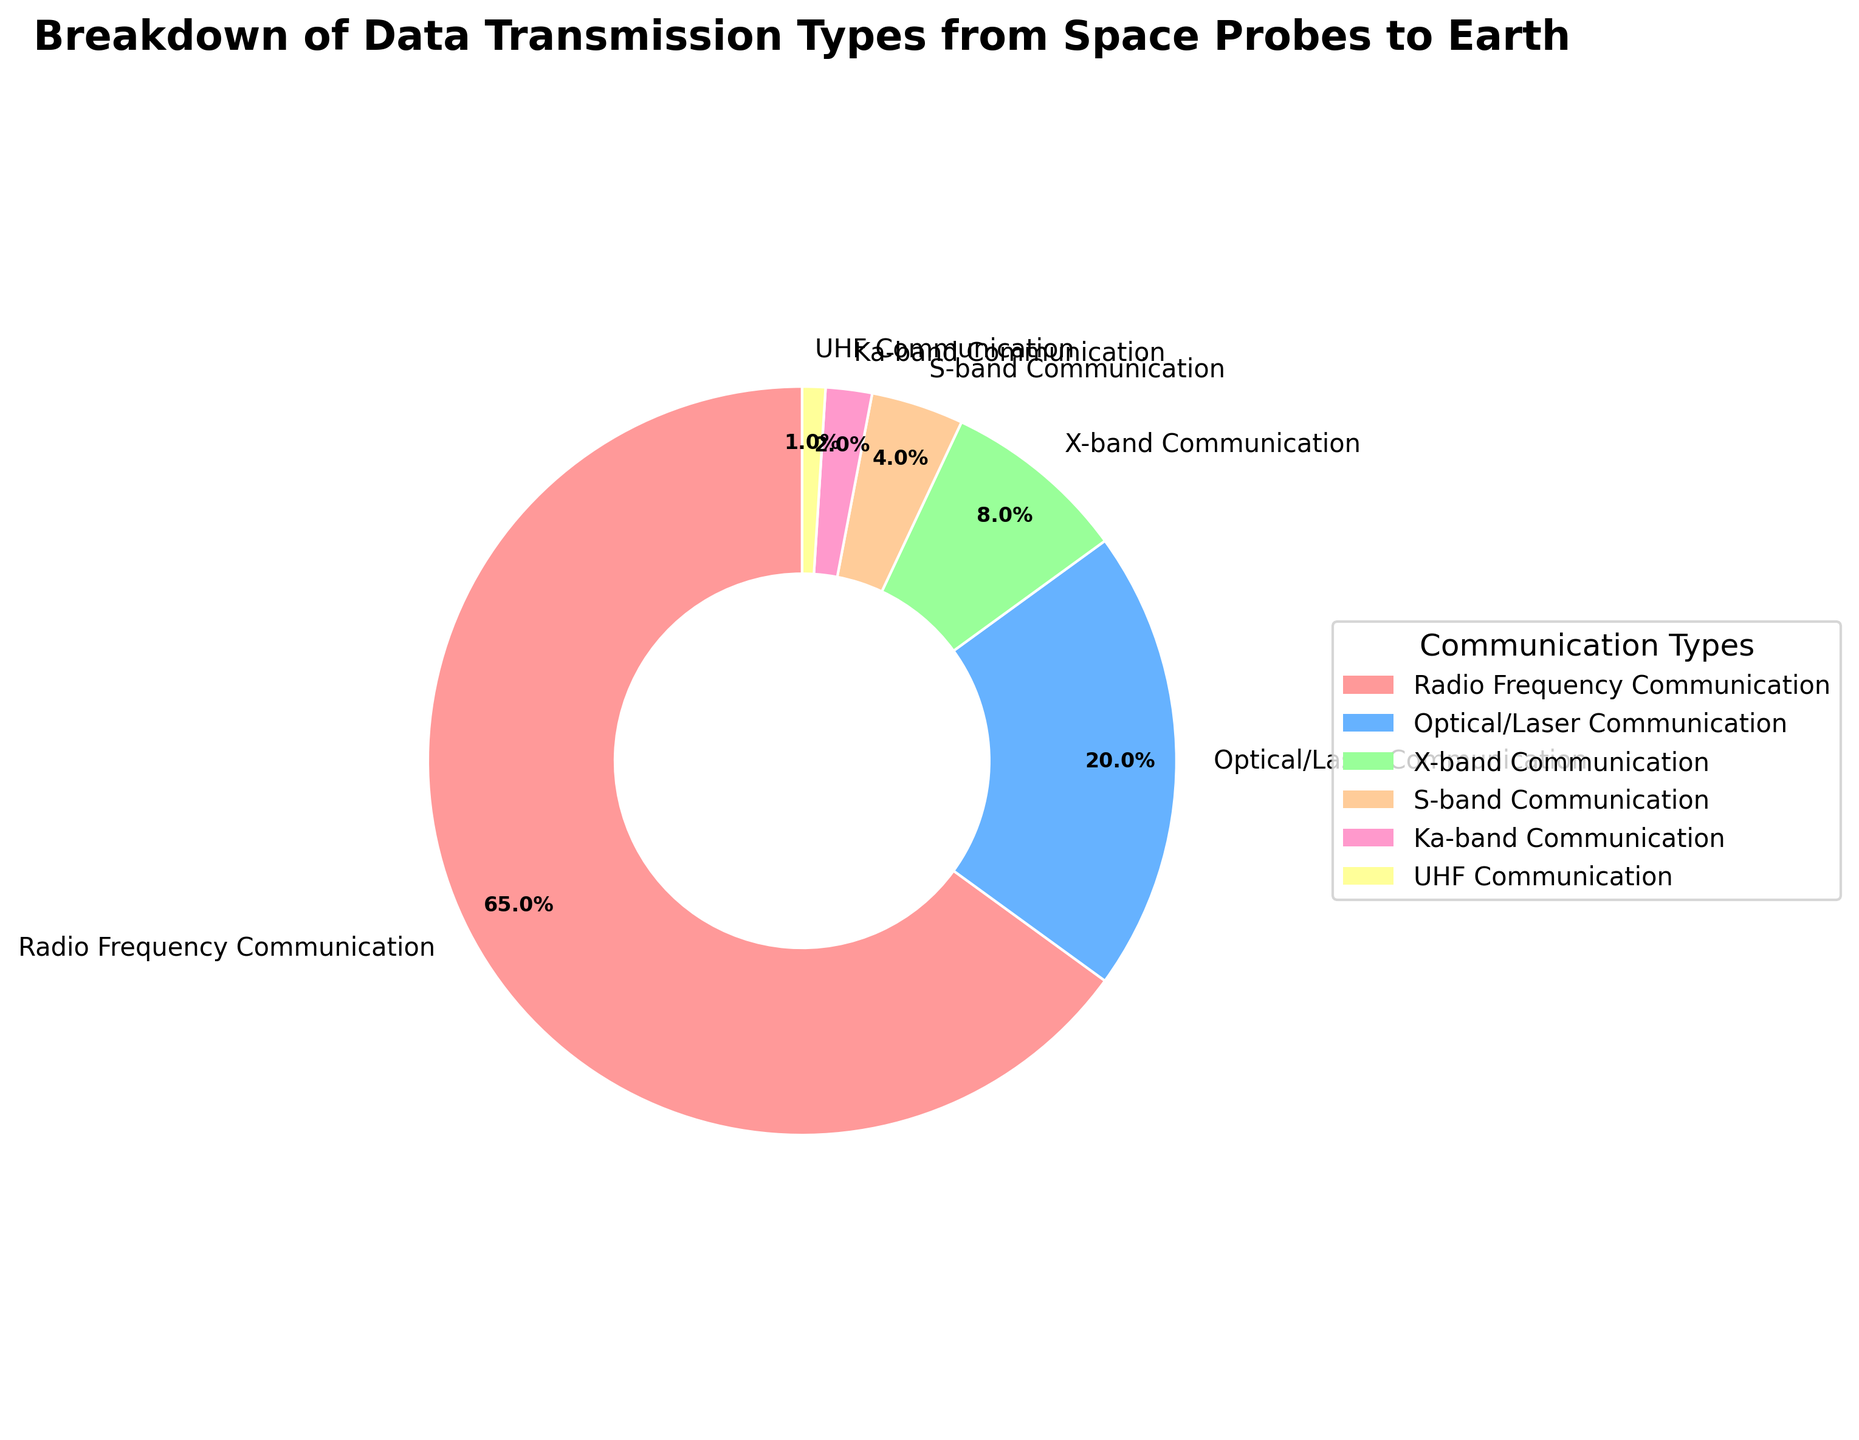What is the most common data transmission type used? The largest segment in the pie chart corresponds to Radio Frequency Communication, which covers 65% of the total. Therefore, it is the most common data transmission type used by space probes to Earth.
Answer: Radio Frequency Communication How much more common is RF Communication compared to Optical/Laser Communication? The RF Communication segment accounts for 65%, while the Optical/Laser Communication is 20%. The difference between these percentages is 65% - 20% = 45%.
Answer: 45% Which communication type is represented by the smallest segment, and what is its percentage? The smallest segment in the pie chart represents UHF Communication, which covers 1% of the total.
Answer: UHF Communication, 1% What is the combined percentage of X-band and S-band Communication? X-band Communication accounts for 8%, and S-band Communication accounts for 4%. Adding these up, 8% + 4% = 12%.
Answer: 12% How many types of communication have a percentage less than 10%? X-band Communication (8%), S-band Communication (4%), Ka-band Communication (2%), and UHF Communication (1%) are all below 10%. There are 4 such types.
Answer: 4 Which segment has a color similar to light blue, and what is its percentage? The segment with a light blue color corresponds to Optical/Laser Communication, which covers 20% of the total.
Answer: Optical/Laser Communication, 20% What percentage of the pie chart is occupied by all communication types other than RF Communication? RF Communication occupies 65%. Subtracting this from 100%, we get 100% - 65% = 35%.
Answer: 35% If you combine all types of communication other than Optical/Laser Communication and RF Communication, what is their total percentage? The percentages for X-band (8%), S-band (4%), Ka-band (2%), and UHF (1%) combined add up to 8% + 4% + 2% + 1% = 15%.
Answer: 15% Is the percentage of Ka-band Communication greater than that of UHF Communication? Ka-band Communication is 2%, whereas UHF Communication is 1%. Thus, Ka-band Communication has a greater percentage.
Answer: Yes Which segments in the chart have a combined percentage of exactly 24%? S-band Communication (4%) and X-band Communication (8%) add up to 12%. Adding Ka-band Communication (2%) to these makes 12% + 2% = 14%. Including UHF Communication (1%) brings the total to 14% + 1% = 15%. This continues until we find that Optical/Laser Communication (20%) together with Ka-band Communication (2%) and S-band Communication (4%) adds up to 20% + 4% = 24%.
Answer: Optical/Laser Communication, Ka-band Communication, S-band Communication 